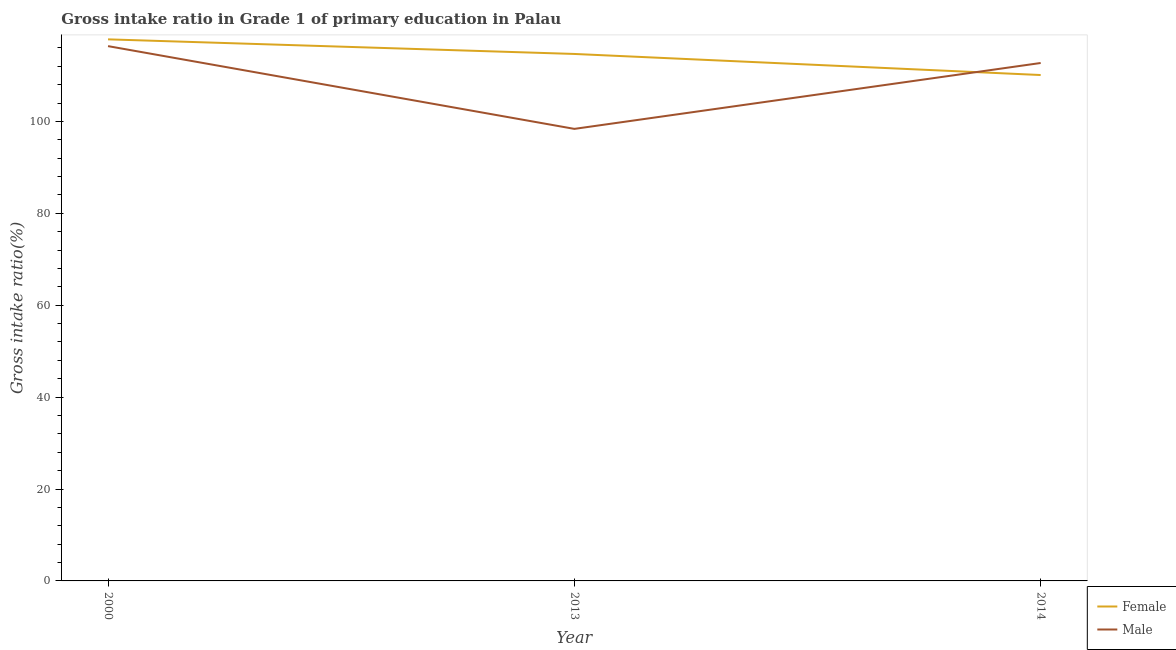What is the gross intake ratio(female) in 2013?
Provide a succinct answer. 114.68. Across all years, what is the maximum gross intake ratio(female)?
Give a very brief answer. 117.86. Across all years, what is the minimum gross intake ratio(female)?
Your answer should be very brief. 110.09. In which year was the gross intake ratio(male) maximum?
Offer a terse response. 2000. In which year was the gross intake ratio(male) minimum?
Provide a short and direct response. 2013. What is the total gross intake ratio(female) in the graph?
Give a very brief answer. 342.63. What is the difference between the gross intake ratio(male) in 2000 and that in 2013?
Provide a succinct answer. 18.01. What is the difference between the gross intake ratio(female) in 2013 and the gross intake ratio(male) in 2000?
Give a very brief answer. -1.71. What is the average gross intake ratio(female) per year?
Offer a terse response. 114.21. In the year 2014, what is the difference between the gross intake ratio(female) and gross intake ratio(male)?
Offer a very short reply. -2.62. What is the ratio of the gross intake ratio(female) in 2013 to that in 2014?
Provide a short and direct response. 1.04. Is the gross intake ratio(female) in 2000 less than that in 2014?
Provide a succinct answer. No. What is the difference between the highest and the second highest gross intake ratio(female)?
Your response must be concise. 3.18. What is the difference between the highest and the lowest gross intake ratio(male)?
Your response must be concise. 18.01. In how many years, is the gross intake ratio(male) greater than the average gross intake ratio(male) taken over all years?
Your answer should be very brief. 2. Does the gross intake ratio(male) monotonically increase over the years?
Your response must be concise. No. Is the gross intake ratio(female) strictly less than the gross intake ratio(male) over the years?
Ensure brevity in your answer.  No. How many lines are there?
Ensure brevity in your answer.  2. What is the difference between two consecutive major ticks on the Y-axis?
Ensure brevity in your answer.  20. Are the values on the major ticks of Y-axis written in scientific E-notation?
Give a very brief answer. No. Where does the legend appear in the graph?
Give a very brief answer. Bottom right. How many legend labels are there?
Ensure brevity in your answer.  2. How are the legend labels stacked?
Your answer should be compact. Vertical. What is the title of the graph?
Provide a short and direct response. Gross intake ratio in Grade 1 of primary education in Palau. What is the label or title of the X-axis?
Offer a very short reply. Year. What is the label or title of the Y-axis?
Your response must be concise. Gross intake ratio(%). What is the Gross intake ratio(%) of Female in 2000?
Make the answer very short. 117.86. What is the Gross intake ratio(%) in Male in 2000?
Offer a terse response. 116.38. What is the Gross intake ratio(%) in Female in 2013?
Keep it short and to the point. 114.68. What is the Gross intake ratio(%) in Male in 2013?
Offer a terse response. 98.37. What is the Gross intake ratio(%) in Female in 2014?
Keep it short and to the point. 110.09. What is the Gross intake ratio(%) in Male in 2014?
Keep it short and to the point. 112.71. Across all years, what is the maximum Gross intake ratio(%) in Female?
Offer a very short reply. 117.86. Across all years, what is the maximum Gross intake ratio(%) of Male?
Give a very brief answer. 116.38. Across all years, what is the minimum Gross intake ratio(%) of Female?
Provide a succinct answer. 110.09. Across all years, what is the minimum Gross intake ratio(%) in Male?
Offer a very short reply. 98.37. What is the total Gross intake ratio(%) in Female in the graph?
Your answer should be very brief. 342.63. What is the total Gross intake ratio(%) of Male in the graph?
Your answer should be very brief. 327.47. What is the difference between the Gross intake ratio(%) of Female in 2000 and that in 2013?
Make the answer very short. 3.18. What is the difference between the Gross intake ratio(%) of Male in 2000 and that in 2013?
Offer a very short reply. 18.01. What is the difference between the Gross intake ratio(%) in Female in 2000 and that in 2014?
Provide a succinct answer. 7.77. What is the difference between the Gross intake ratio(%) in Male in 2000 and that in 2014?
Your answer should be very brief. 3.67. What is the difference between the Gross intake ratio(%) in Female in 2013 and that in 2014?
Provide a succinct answer. 4.59. What is the difference between the Gross intake ratio(%) in Male in 2013 and that in 2014?
Your answer should be compact. -14.34. What is the difference between the Gross intake ratio(%) of Female in 2000 and the Gross intake ratio(%) of Male in 2013?
Keep it short and to the point. 19.48. What is the difference between the Gross intake ratio(%) in Female in 2000 and the Gross intake ratio(%) in Male in 2014?
Offer a very short reply. 5.15. What is the difference between the Gross intake ratio(%) in Female in 2013 and the Gross intake ratio(%) in Male in 2014?
Your answer should be compact. 1.97. What is the average Gross intake ratio(%) in Female per year?
Make the answer very short. 114.21. What is the average Gross intake ratio(%) of Male per year?
Offer a terse response. 109.16. In the year 2000, what is the difference between the Gross intake ratio(%) of Female and Gross intake ratio(%) of Male?
Your answer should be very brief. 1.47. In the year 2013, what is the difference between the Gross intake ratio(%) of Female and Gross intake ratio(%) of Male?
Provide a short and direct response. 16.3. In the year 2014, what is the difference between the Gross intake ratio(%) in Female and Gross intake ratio(%) in Male?
Make the answer very short. -2.62. What is the ratio of the Gross intake ratio(%) of Female in 2000 to that in 2013?
Make the answer very short. 1.03. What is the ratio of the Gross intake ratio(%) of Male in 2000 to that in 2013?
Your answer should be very brief. 1.18. What is the ratio of the Gross intake ratio(%) of Female in 2000 to that in 2014?
Make the answer very short. 1.07. What is the ratio of the Gross intake ratio(%) in Male in 2000 to that in 2014?
Ensure brevity in your answer.  1.03. What is the ratio of the Gross intake ratio(%) in Female in 2013 to that in 2014?
Offer a very short reply. 1.04. What is the ratio of the Gross intake ratio(%) of Male in 2013 to that in 2014?
Make the answer very short. 0.87. What is the difference between the highest and the second highest Gross intake ratio(%) of Female?
Keep it short and to the point. 3.18. What is the difference between the highest and the second highest Gross intake ratio(%) of Male?
Offer a terse response. 3.67. What is the difference between the highest and the lowest Gross intake ratio(%) in Female?
Ensure brevity in your answer.  7.77. What is the difference between the highest and the lowest Gross intake ratio(%) of Male?
Keep it short and to the point. 18.01. 